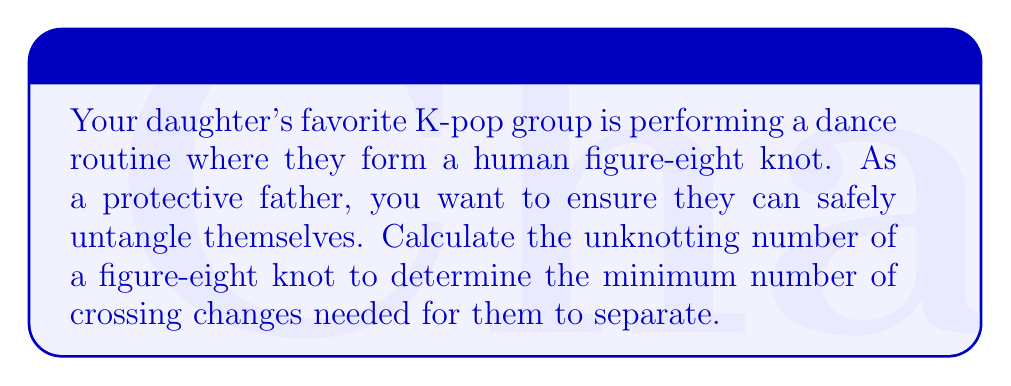Give your solution to this math problem. Let's approach this step-by-step:

1) The figure-eight knot, also known as the 4₁ knot in knot theory, is the simplest non-trivial knot.

2) To calculate the unknotting number, we need to determine the minimum number of crossing changes required to transform the knot into an unknot (trivial knot).

3) The figure-eight knot can be represented by the following diagram:

[asy]
import geometry;

pair A = (0,0), B = (1,0), C = (2,0), D = (3,0);
pair E = (0.5,0.5), F = (1.5,0.5), G = (2.5,0.5);
pair H = (1,-0.5), I = (2,-0.5);

draw(A--E--B--F--C--G--D);
draw(B--H--C, dashed);
draw(C--I--B, dashed);

label("1", (0.5,0.25), N);
label("2", (1.5,0.25), N);
label("3", (2.5,0.25), N);
label("4", (1.5,-0.25), S);
[/asy]

4) The figure-eight knot has a crossing number of 4, which means it has 4 crossings in its minimal diagram.

5) However, the unknotting number is not always equal to the crossing number. In this case, we can unknot the figure-eight knot by changing just one crossing.

6) Specifically, if we change either crossing 1 or crossing 3 in the diagram, the knot will become an unknot.

7) Therefore, the unknotting number of the figure-eight knot is 1.

This means your daughter's K-pop group only needs to make one change in their human knot formation to safely untangle themselves.
Answer: 1 